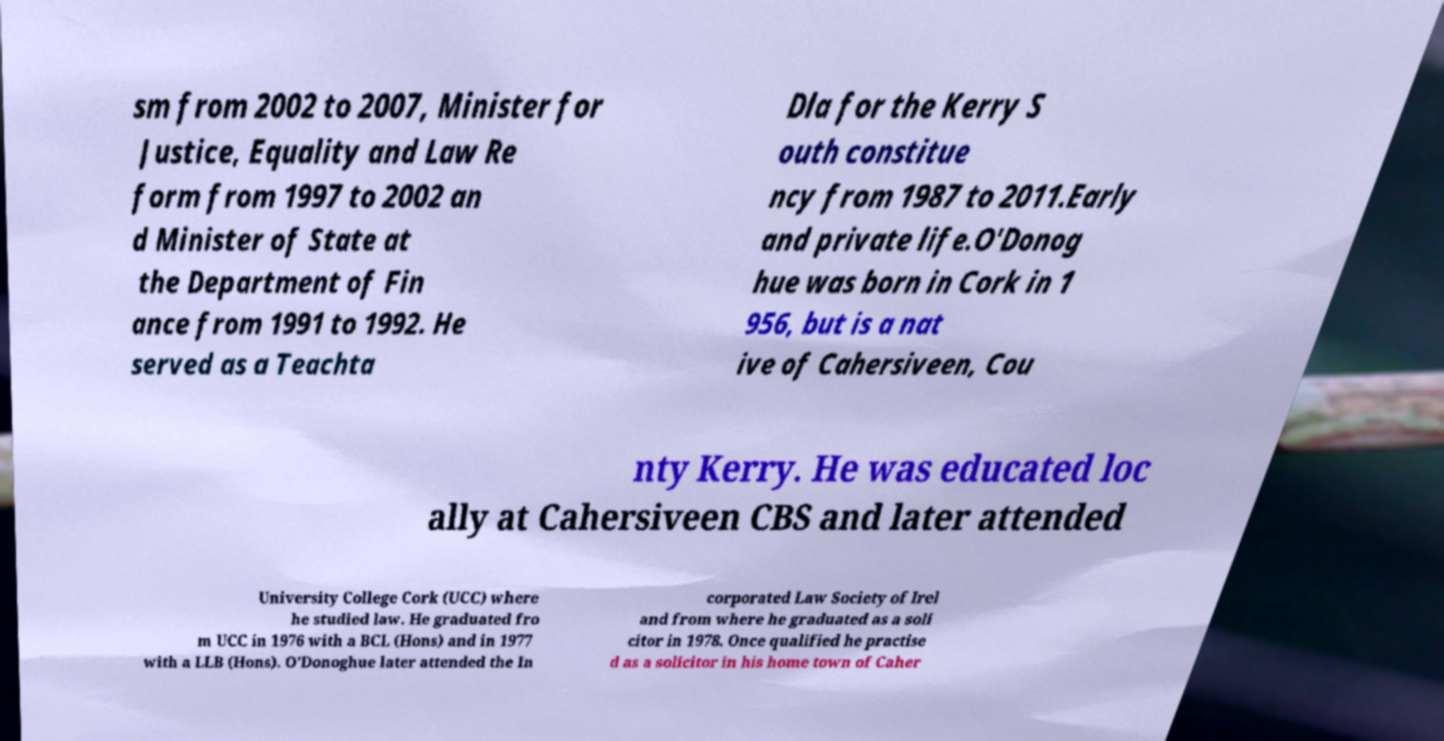I need the written content from this picture converted into text. Can you do that? sm from 2002 to 2007, Minister for Justice, Equality and Law Re form from 1997 to 2002 an d Minister of State at the Department of Fin ance from 1991 to 1992. He served as a Teachta Dla for the Kerry S outh constitue ncy from 1987 to 2011.Early and private life.O'Donog hue was born in Cork in 1 956, but is a nat ive of Cahersiveen, Cou nty Kerry. He was educated loc ally at Cahersiveen CBS and later attended University College Cork (UCC) where he studied law. He graduated fro m UCC in 1976 with a BCL (Hons) and in 1977 with a LLB (Hons). O'Donoghue later attended the In corporated Law Society of Irel and from where he graduated as a soli citor in 1978. Once qualified he practise d as a solicitor in his home town of Caher 